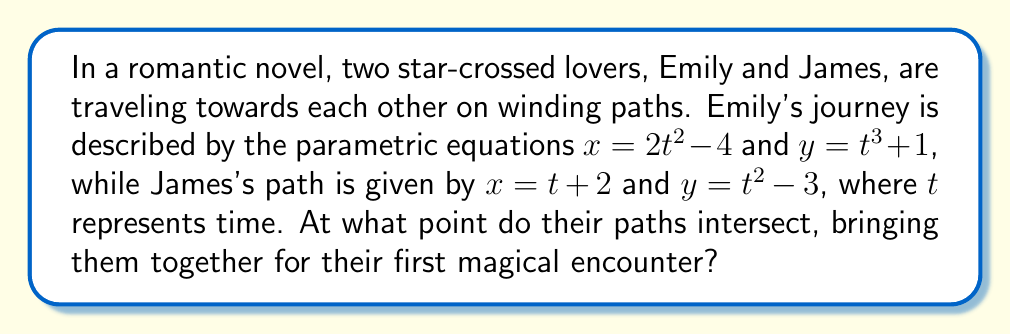Help me with this question. To find the intersection point of Emily and James's paths, we need to solve the system of equations:

1) First, let's equate the x-coordinates:
   $2t^2 - 4 = s + 2$  (where $t$ is Emily's time parameter and $s$ is James's)

2) Next, equate the y-coordinates:
   $t^3 + 1 = s^2 - 3$

3) From the first equation, we can express $s$ in terms of $t$:
   $s = 2t^2 - 6$

4) Substitute this into the second equation:
   $t^3 + 1 = (2t^2 - 6)^2 - 3$

5) Expand the right side:
   $t^3 + 1 = 4t^4 - 24t^2 + 36 - 3$
   $t^3 + 1 = 4t^4 - 24t^2 + 33$

6) Rearrange the equation:
   $4t^4 - t^3 - 24t^2 + 32 = 0$

7) This is a fourth-degree polynomial equation. It can be solved by factoring:
   $(4t^2 + 8t - 4)(t^2 - 2t - 8) = 0$

8) Solve each factor:
   $4t^2 + 8t - 4 = 0$ gives $t = -2$ or $t = \frac{1}{2}$
   $t^2 - 2t - 8 = 0$ gives $t = -2$ or $t = 4$

9) The only positive, real solution is $t = 4$ (since time is usually positive in this context)

10) Substitute $t = 4$ into Emily's equations:
    $x = 2(4)^2 - 4 = 28$
    $y = 4^3 + 1 = 65$

Therefore, Emily and James's paths intersect at the point (28, 65).
Answer: The lovers' paths intersect at the point (28, 65). 